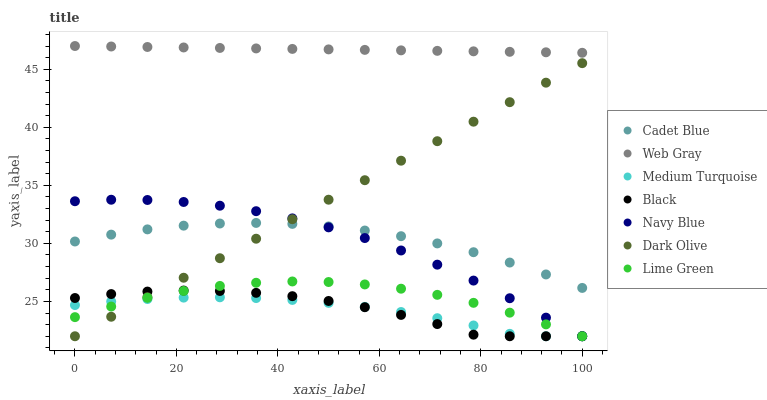Does Medium Turquoise have the minimum area under the curve?
Answer yes or no. Yes. Does Web Gray have the maximum area under the curve?
Answer yes or no. Yes. Does Navy Blue have the minimum area under the curve?
Answer yes or no. No. Does Navy Blue have the maximum area under the curve?
Answer yes or no. No. Is Web Gray the smoothest?
Answer yes or no. Yes. Is Black the roughest?
Answer yes or no. Yes. Is Navy Blue the smoothest?
Answer yes or no. No. Is Navy Blue the roughest?
Answer yes or no. No. Does Navy Blue have the lowest value?
Answer yes or no. Yes. Does Web Gray have the lowest value?
Answer yes or no. No. Does Web Gray have the highest value?
Answer yes or no. Yes. Does Navy Blue have the highest value?
Answer yes or no. No. Is Black less than Cadet Blue?
Answer yes or no. Yes. Is Cadet Blue greater than Lime Green?
Answer yes or no. Yes. Does Dark Olive intersect Medium Turquoise?
Answer yes or no. Yes. Is Dark Olive less than Medium Turquoise?
Answer yes or no. No. Is Dark Olive greater than Medium Turquoise?
Answer yes or no. No. Does Black intersect Cadet Blue?
Answer yes or no. No. 